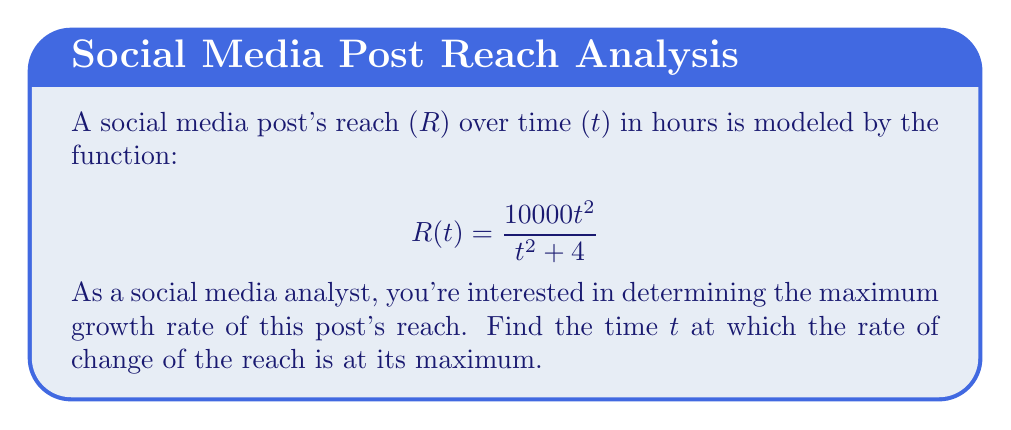Can you solve this math problem? To find the maximum growth rate, we need to follow these steps:

1) First, calculate the derivative of R(t) with respect to t:
   $$ R'(t) = \frac{d}{dt}\left(\frac{10000t^2}{t^2 + 4}\right) $$
   Using the quotient rule, we get:
   $$ R'(t) = \frac{20000t(t^2+4) - 10000t^2(2t)}{(t^2+4)^2} $$
   $$ R'(t) = \frac{20000t^3 + 80000t - 20000t^3}{(t^2+4)^2} $$
   $$ R'(t) = \frac{80000t}{(t^2+4)^2} $$

2) To find the maximum of R'(t), we need to find where its derivative equals zero:
   $$ \frac{d}{dt}R'(t) = \frac{80000(t^2+4)^2 - 80000t \cdot 2(t^2+4) \cdot 2t}{(t^2+4)^4} = 0 $$
   $$ 80000(t^2+4)^2 - 320000t^2(t^2+4) = 0 $$
   $$ (t^2+4)^2 - 4t^2(t^2+4) = 0 $$
   $$ t^4 + 8t^2 + 16 - 4t^4 - 16t^2 = 0 $$
   $$ -3t^4 - 8t^2 + 16 = 0 $$

3) Let $u = t^2$. Then we have:
   $$ -3u^2 - 8u + 16 = 0 $$

4) Solving this quadratic equation:
   $$ u = \frac{-8 \pm \sqrt{64 + 192}}{-6} = \frac{-8 \pm \sqrt{256}}{-6} = \frac{-8 \pm 16}{-6} $$
   $$ u = \frac{4}{3} \text{ or } u = -4 \text{ (discard as t^2 cannot be negative)} $$

5) Since $u = t^2 = \frac{4}{3}$, we have:
   $$ t = \pm \sqrt{\frac{4}{3}} = \pm \frac{2}{\sqrt{3}} $$

6) As time cannot be negative, we take the positive value:
   $$ t = \frac{2}{\sqrt{3}} $$

This is the time at which the growth rate (R'(t)) is at its maximum.
Answer: $\frac{2}{\sqrt{3}}$ hours 